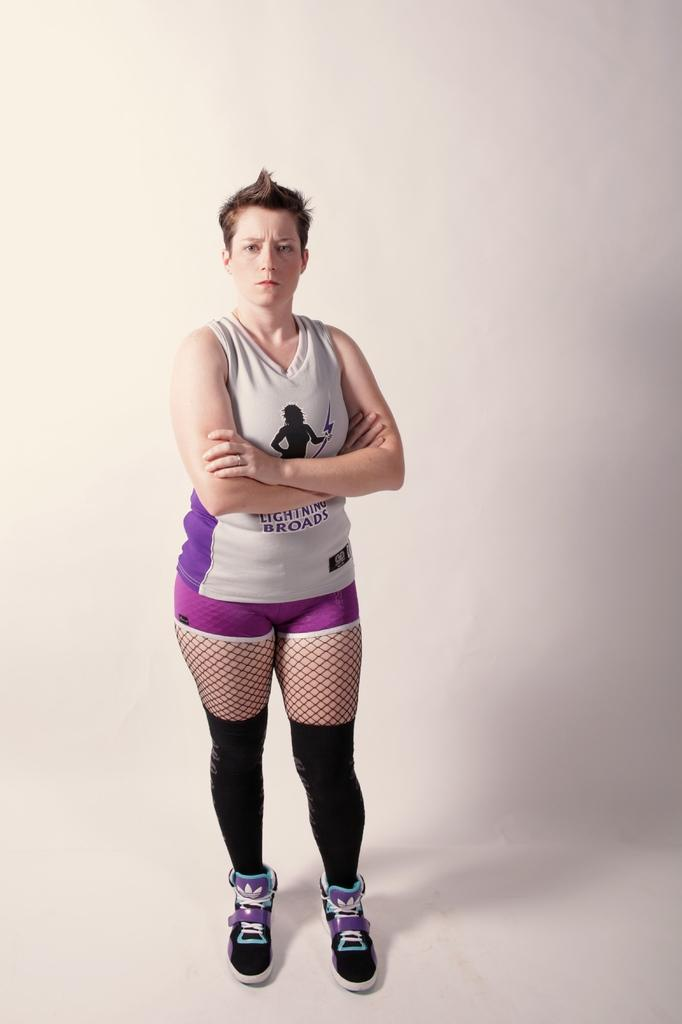Who is present in the image? There is a person in the image. What is the person doing in the image? The person is standing on the floor. What chess move is the person making in the image? There is no chess board or pieces present in the image. 